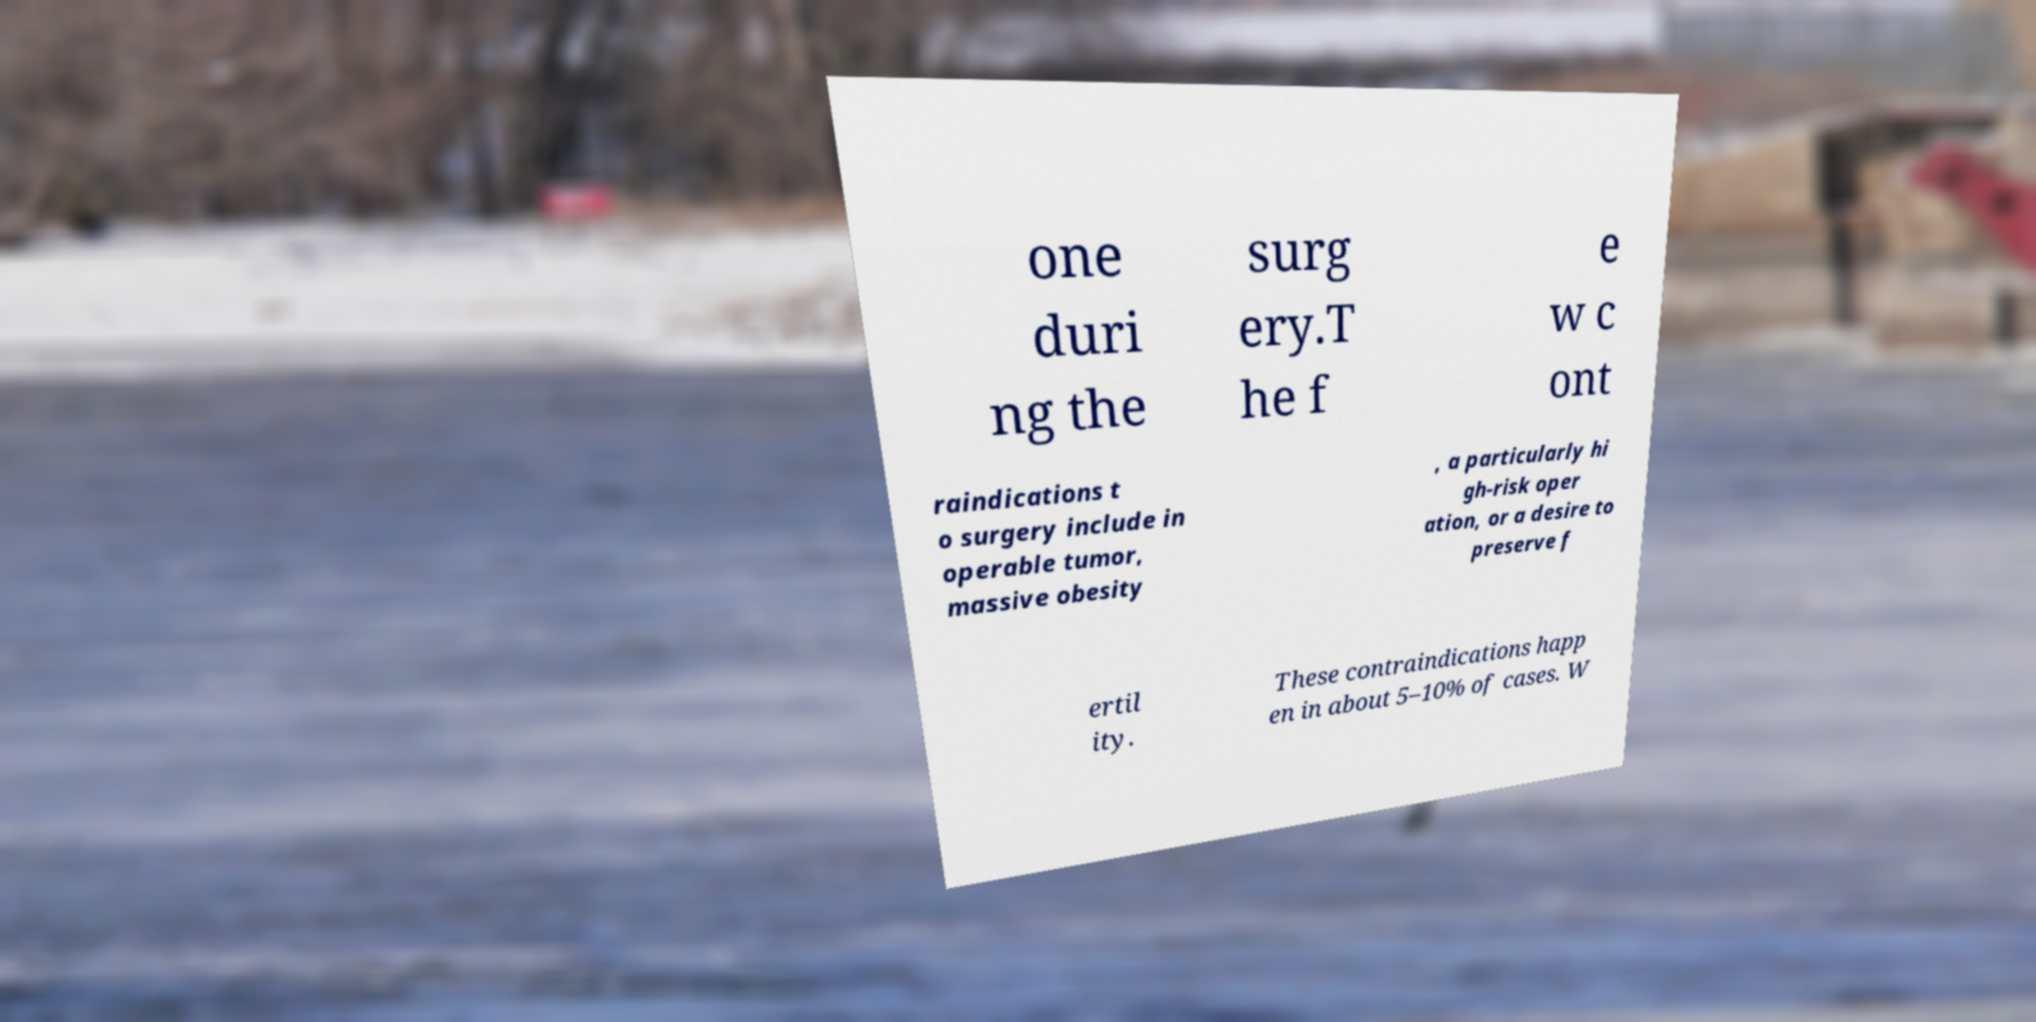Can you accurately transcribe the text from the provided image for me? one duri ng the surg ery.T he f e w c ont raindications t o surgery include in operable tumor, massive obesity , a particularly hi gh-risk oper ation, or a desire to preserve f ertil ity. These contraindications happ en in about 5–10% of cases. W 